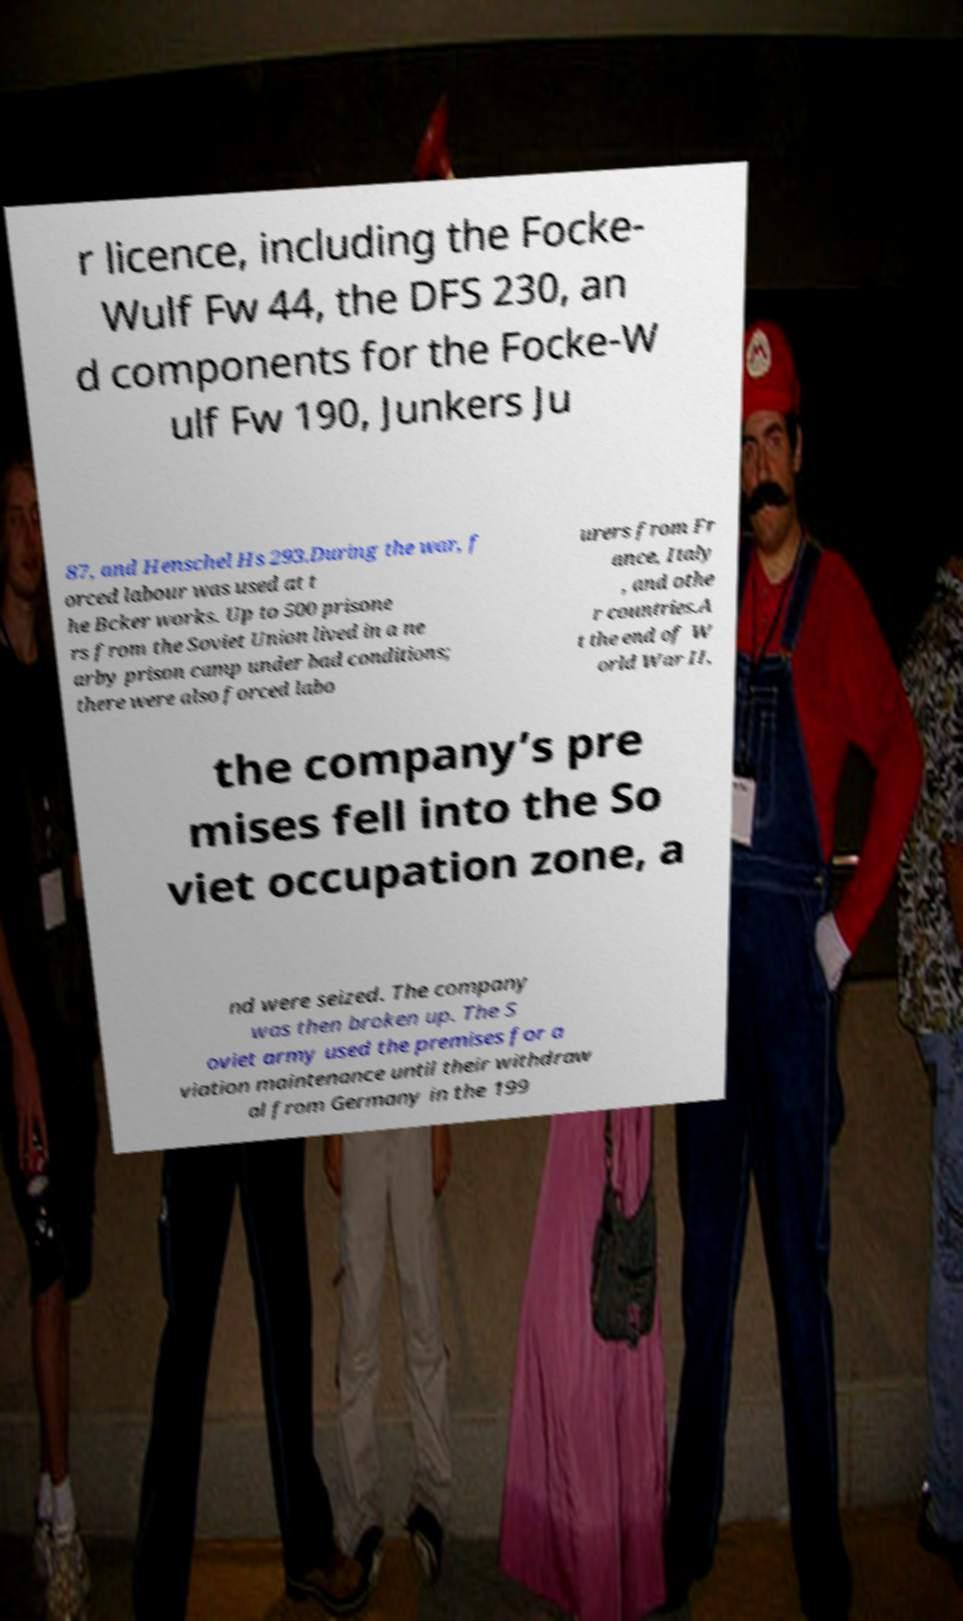There's text embedded in this image that I need extracted. Can you transcribe it verbatim? r licence, including the Focke- Wulf Fw 44, the DFS 230, an d components for the Focke-W ulf Fw 190, Junkers Ju 87, and Henschel Hs 293.During the war, f orced labour was used at t he Bcker works. Up to 500 prisone rs from the Soviet Union lived in a ne arby prison camp under bad conditions; there were also forced labo urers from Fr ance, Italy , and othe r countries.A t the end of W orld War II, the company’s pre mises fell into the So viet occupation zone, a nd were seized. The company was then broken up. The S oviet army used the premises for a viation maintenance until their withdraw al from Germany in the 199 